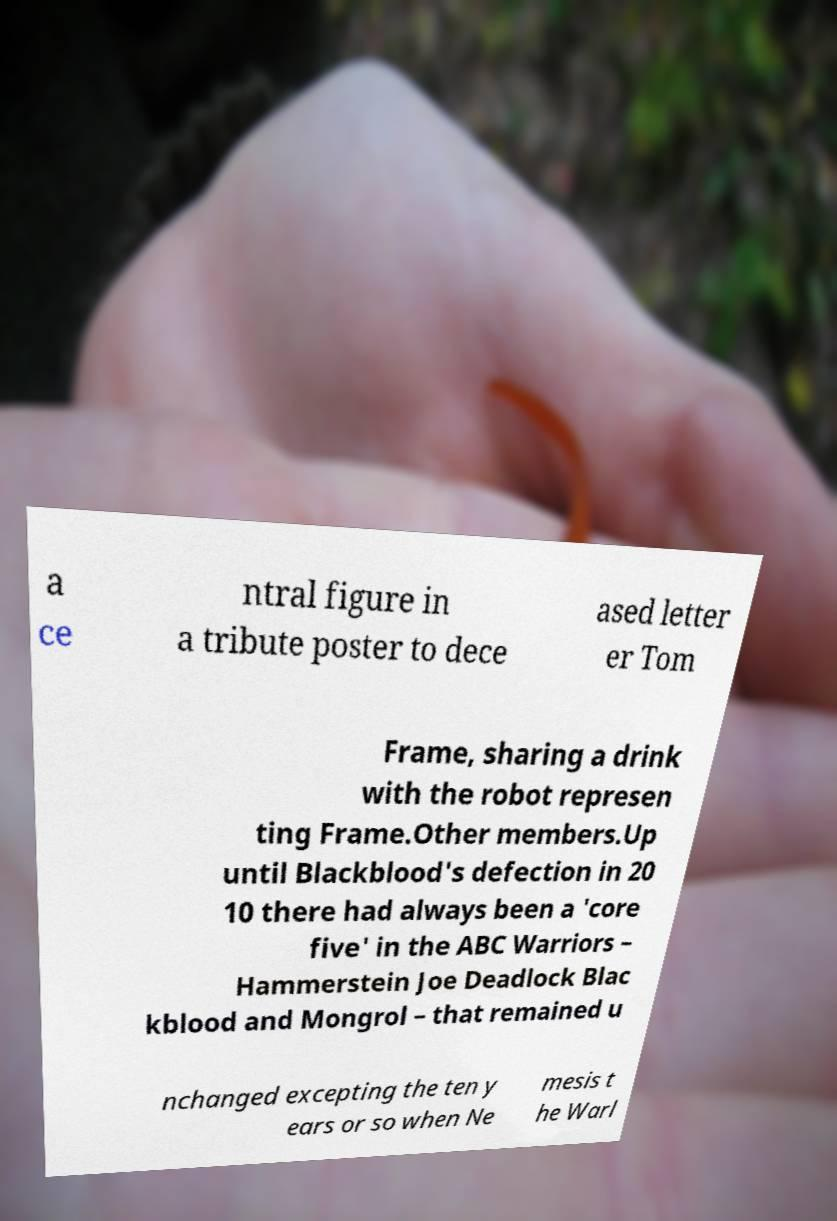Can you read and provide the text displayed in the image?This photo seems to have some interesting text. Can you extract and type it out for me? a ce ntral figure in a tribute poster to dece ased letter er Tom Frame, sharing a drink with the robot represen ting Frame.Other members.Up until Blackblood's defection in 20 10 there had always been a 'core five' in the ABC Warriors – Hammerstein Joe Deadlock Blac kblood and Mongrol – that remained u nchanged excepting the ten y ears or so when Ne mesis t he Warl 